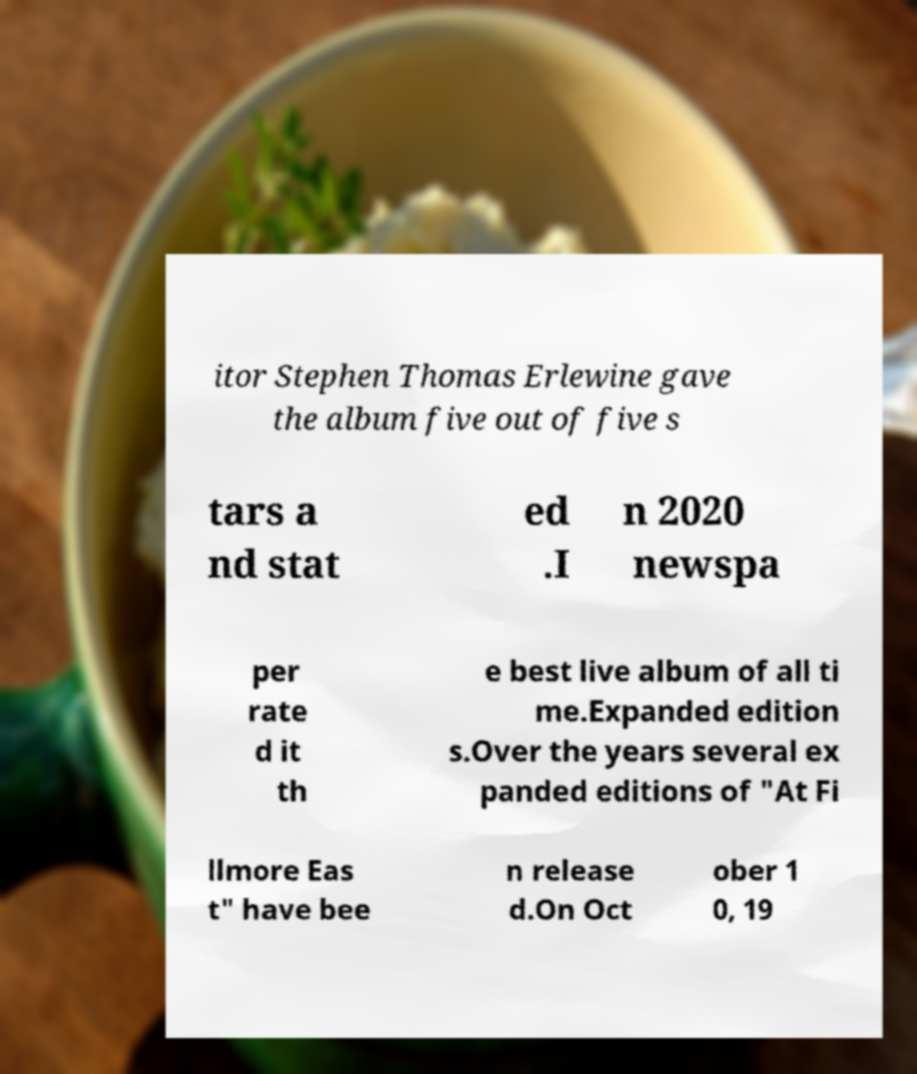Please identify and transcribe the text found in this image. itor Stephen Thomas Erlewine gave the album five out of five s tars a nd stat ed .I n 2020 newspa per rate d it th e best live album of all ti me.Expanded edition s.Over the years several ex panded editions of "At Fi llmore Eas t" have bee n release d.On Oct ober 1 0, 19 